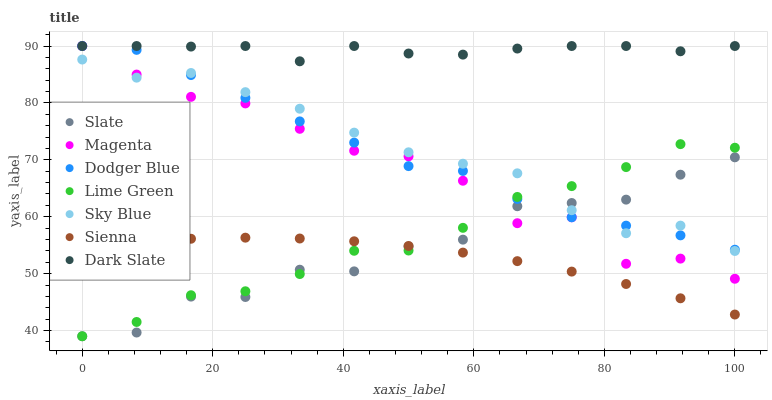Does Sienna have the minimum area under the curve?
Answer yes or no. Yes. Does Dark Slate have the maximum area under the curve?
Answer yes or no. Yes. Does Dark Slate have the minimum area under the curve?
Answer yes or no. No. Does Sienna have the maximum area under the curve?
Answer yes or no. No. Is Sienna the smoothest?
Answer yes or no. Yes. Is Magenta the roughest?
Answer yes or no. Yes. Is Dark Slate the smoothest?
Answer yes or no. No. Is Dark Slate the roughest?
Answer yes or no. No. Does Slate have the lowest value?
Answer yes or no. Yes. Does Sienna have the lowest value?
Answer yes or no. No. Does Magenta have the highest value?
Answer yes or no. Yes. Does Sienna have the highest value?
Answer yes or no. No. Is Lime Green less than Dark Slate?
Answer yes or no. Yes. Is Dark Slate greater than Lime Green?
Answer yes or no. Yes. Does Lime Green intersect Slate?
Answer yes or no. Yes. Is Lime Green less than Slate?
Answer yes or no. No. Is Lime Green greater than Slate?
Answer yes or no. No. Does Lime Green intersect Dark Slate?
Answer yes or no. No. 